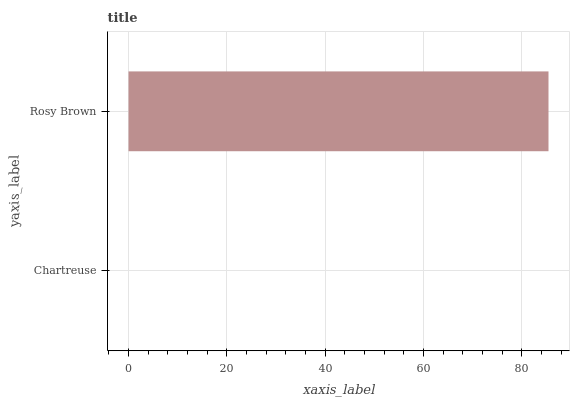Is Chartreuse the minimum?
Answer yes or no. Yes. Is Rosy Brown the maximum?
Answer yes or no. Yes. Is Rosy Brown the minimum?
Answer yes or no. No. Is Rosy Brown greater than Chartreuse?
Answer yes or no. Yes. Is Chartreuse less than Rosy Brown?
Answer yes or no. Yes. Is Chartreuse greater than Rosy Brown?
Answer yes or no. No. Is Rosy Brown less than Chartreuse?
Answer yes or no. No. Is Rosy Brown the high median?
Answer yes or no. Yes. Is Chartreuse the low median?
Answer yes or no. Yes. Is Chartreuse the high median?
Answer yes or no. No. Is Rosy Brown the low median?
Answer yes or no. No. 